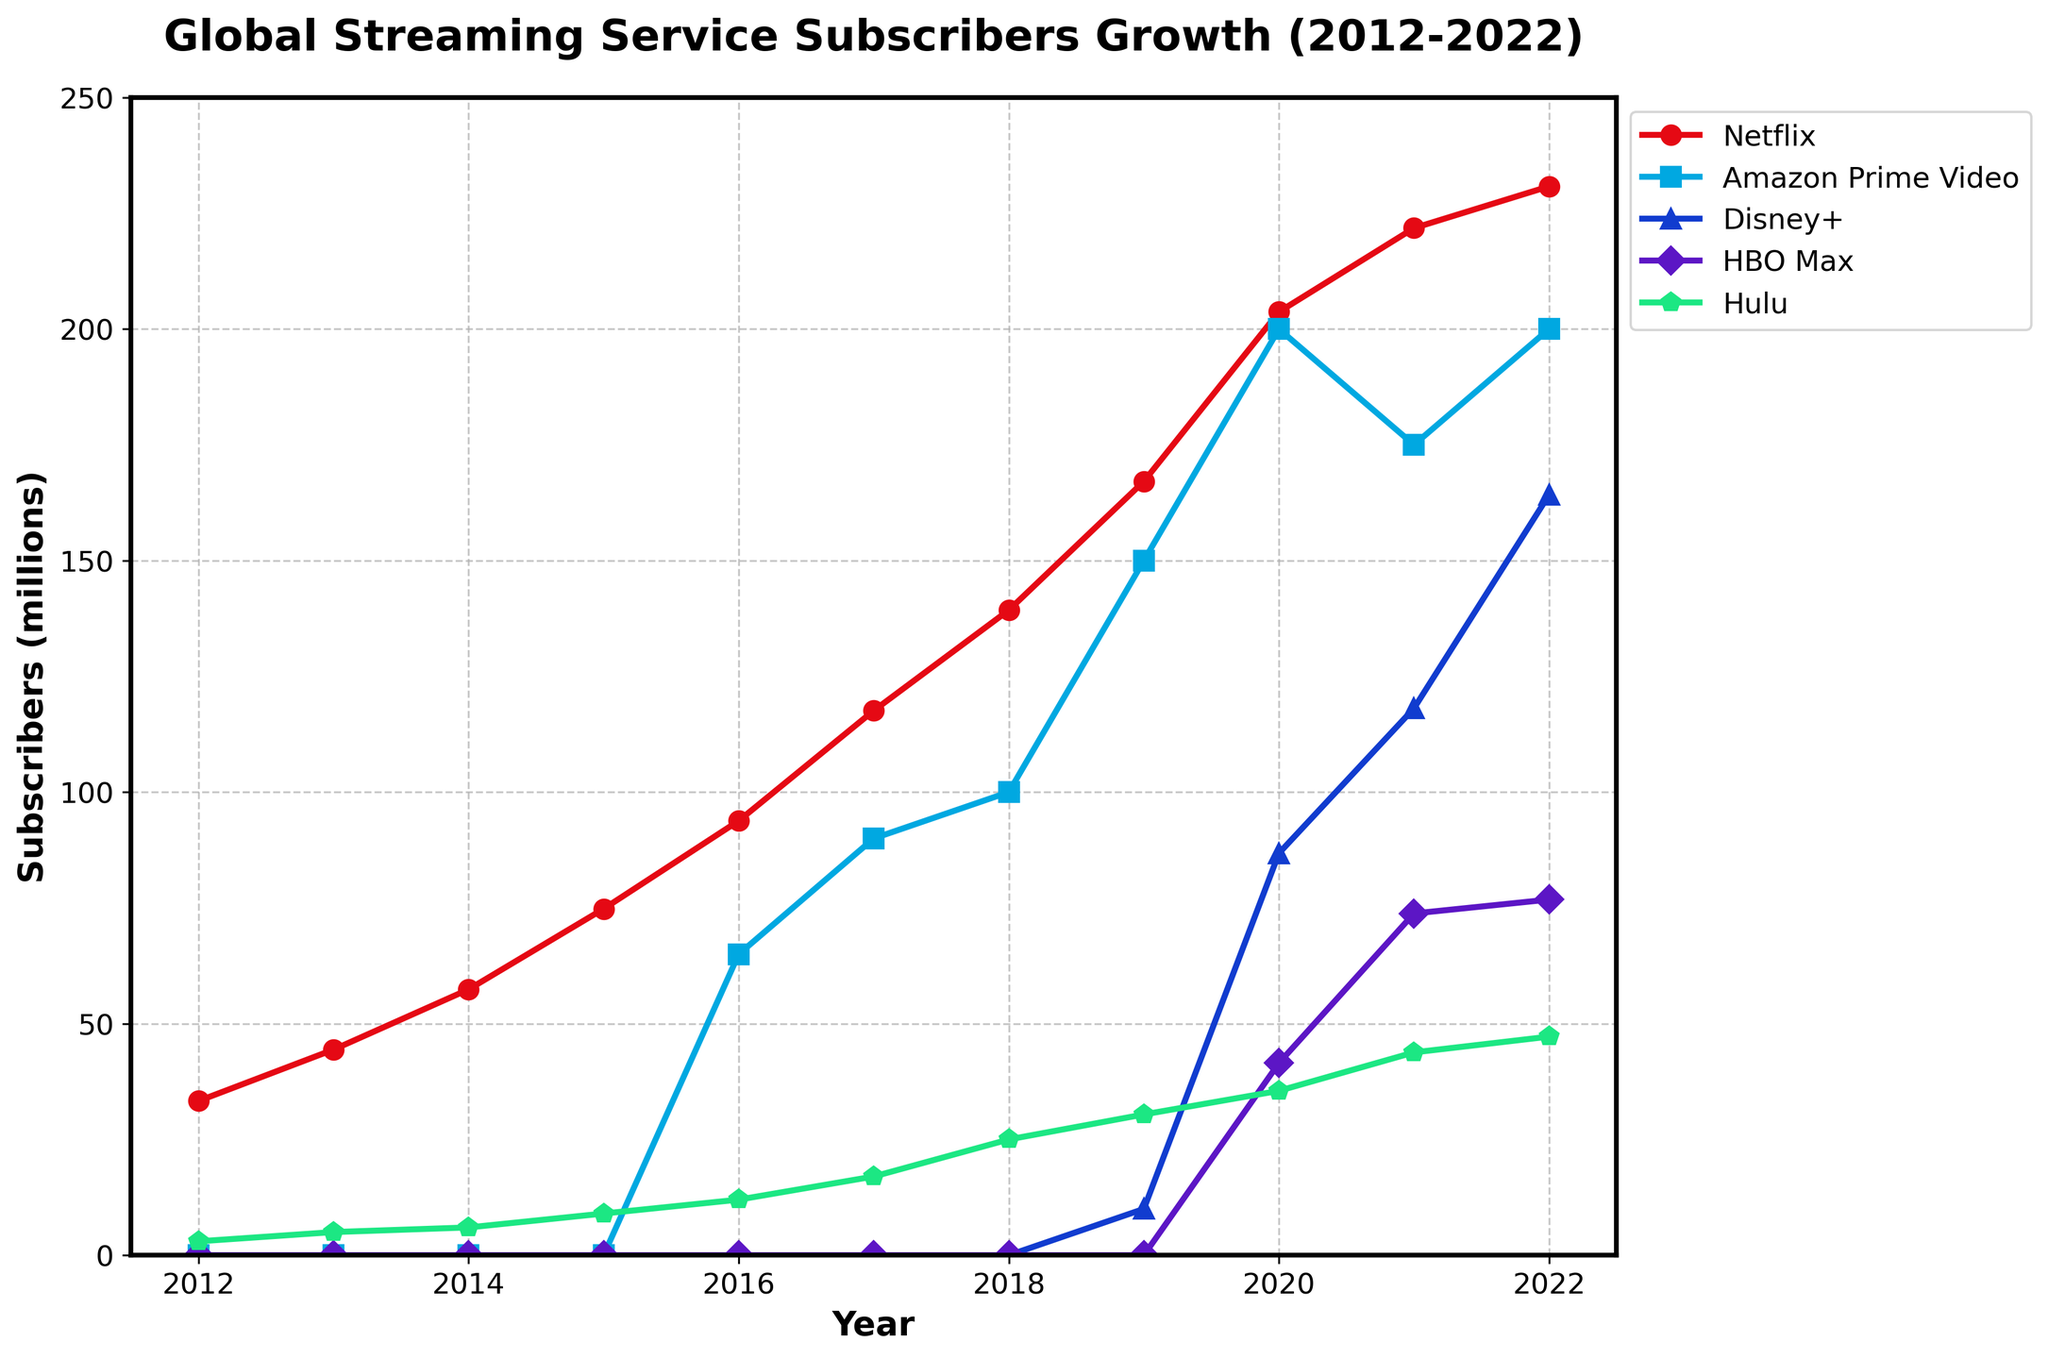Which platform had the highest number of subscribers in 2022? Look at the ending points of the lines on the right side of the plot. Netflix's line is the highest in 2022.
Answer: Netflix Which year saw Disney+ exceed 100 million subscribers? Observe the Disney+ line where it crosses the 100 million mark. It crosses between 2020 and 2021.
Answer: 2021 How much was the subscriber growth for Netflix from 2012 to 2022? Calculate the difference between the Netflix values in 2022 and 2012. 230.8 - 33.3 = 197.5 million.
Answer: 197.5 million Which platform had the smallest subscriber base in 2015? Compare the markers at 2015 for each platform. Only Netflix and Hulu had subscribers then, with Hulu having fewer.
Answer: Hulu By what factor did HBO Max's subscribers increase from 2020 to 2022? Divide HBO Max subscribers in 2022 by those in 2020. 76.8 / 41.5 = 1.85.
Answer: 1.85 Which platform had the steepest growth between 2019 and 2020? Look at the lines' slopes between 2019 and 2020. Disney+ has the steepest increase.
Answer: Disney+ How many platforms had more than 100 million subscribers in 2022? Count the lines above the 100 million mark in 2022. Netflix, Amazon Prime Video, and Disney+. Three platforms.
Answer: 3 What was the combined number of subscribers for Netflix and Amazon Prime Video in 2016? Sum the values for Netflix and Amazon Prime Video in 2016: 93.8 + 65 = 158.8 million.
Answer: 158.8 million Which platform had consistent subscriber growth each year? Identify lines without any drops. Netflix and Disney+ show consistent growth.
Answer: Netflix and Disney+ What is the difference in subscribers between Netflix and Hulu in 2020? Subtract Hulu's subscribers from Netflix's subscribers in 2020: 203.7 - 35.5 = 168.2 million.
Answer: 168.2 million 